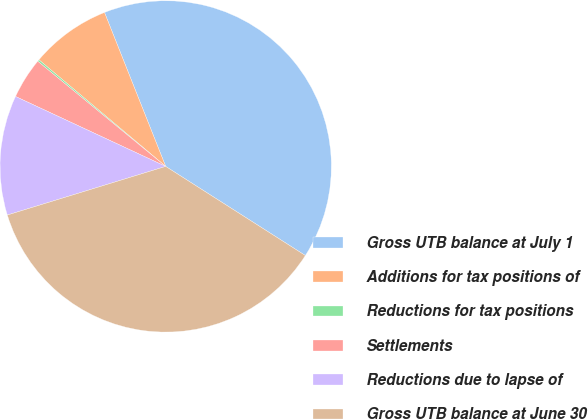<chart> <loc_0><loc_0><loc_500><loc_500><pie_chart><fcel>Gross UTB balance at July 1<fcel>Additions for tax positions of<fcel>Reductions for tax positions<fcel>Settlements<fcel>Reductions due to lapse of<fcel>Gross UTB balance at June 30<nl><fcel>40.06%<fcel>7.85%<fcel>0.18%<fcel>4.01%<fcel>11.68%<fcel>36.22%<nl></chart> 